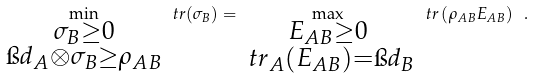<formula> <loc_0><loc_0><loc_500><loc_500>\min _ { \substack { \sigma _ { B } \geq 0 \\ \i d _ { A } \otimes \sigma _ { B } \geq \rho _ { A B } } } \ t r ( \sigma _ { B } ) = \max _ { \substack { E _ { A B } \geq 0 \\ \ t r _ { A } ( E _ { A B } ) = \i d _ { B } } } \ t r \left ( \rho _ { A B } E _ { A B } \right ) \ .</formula> 